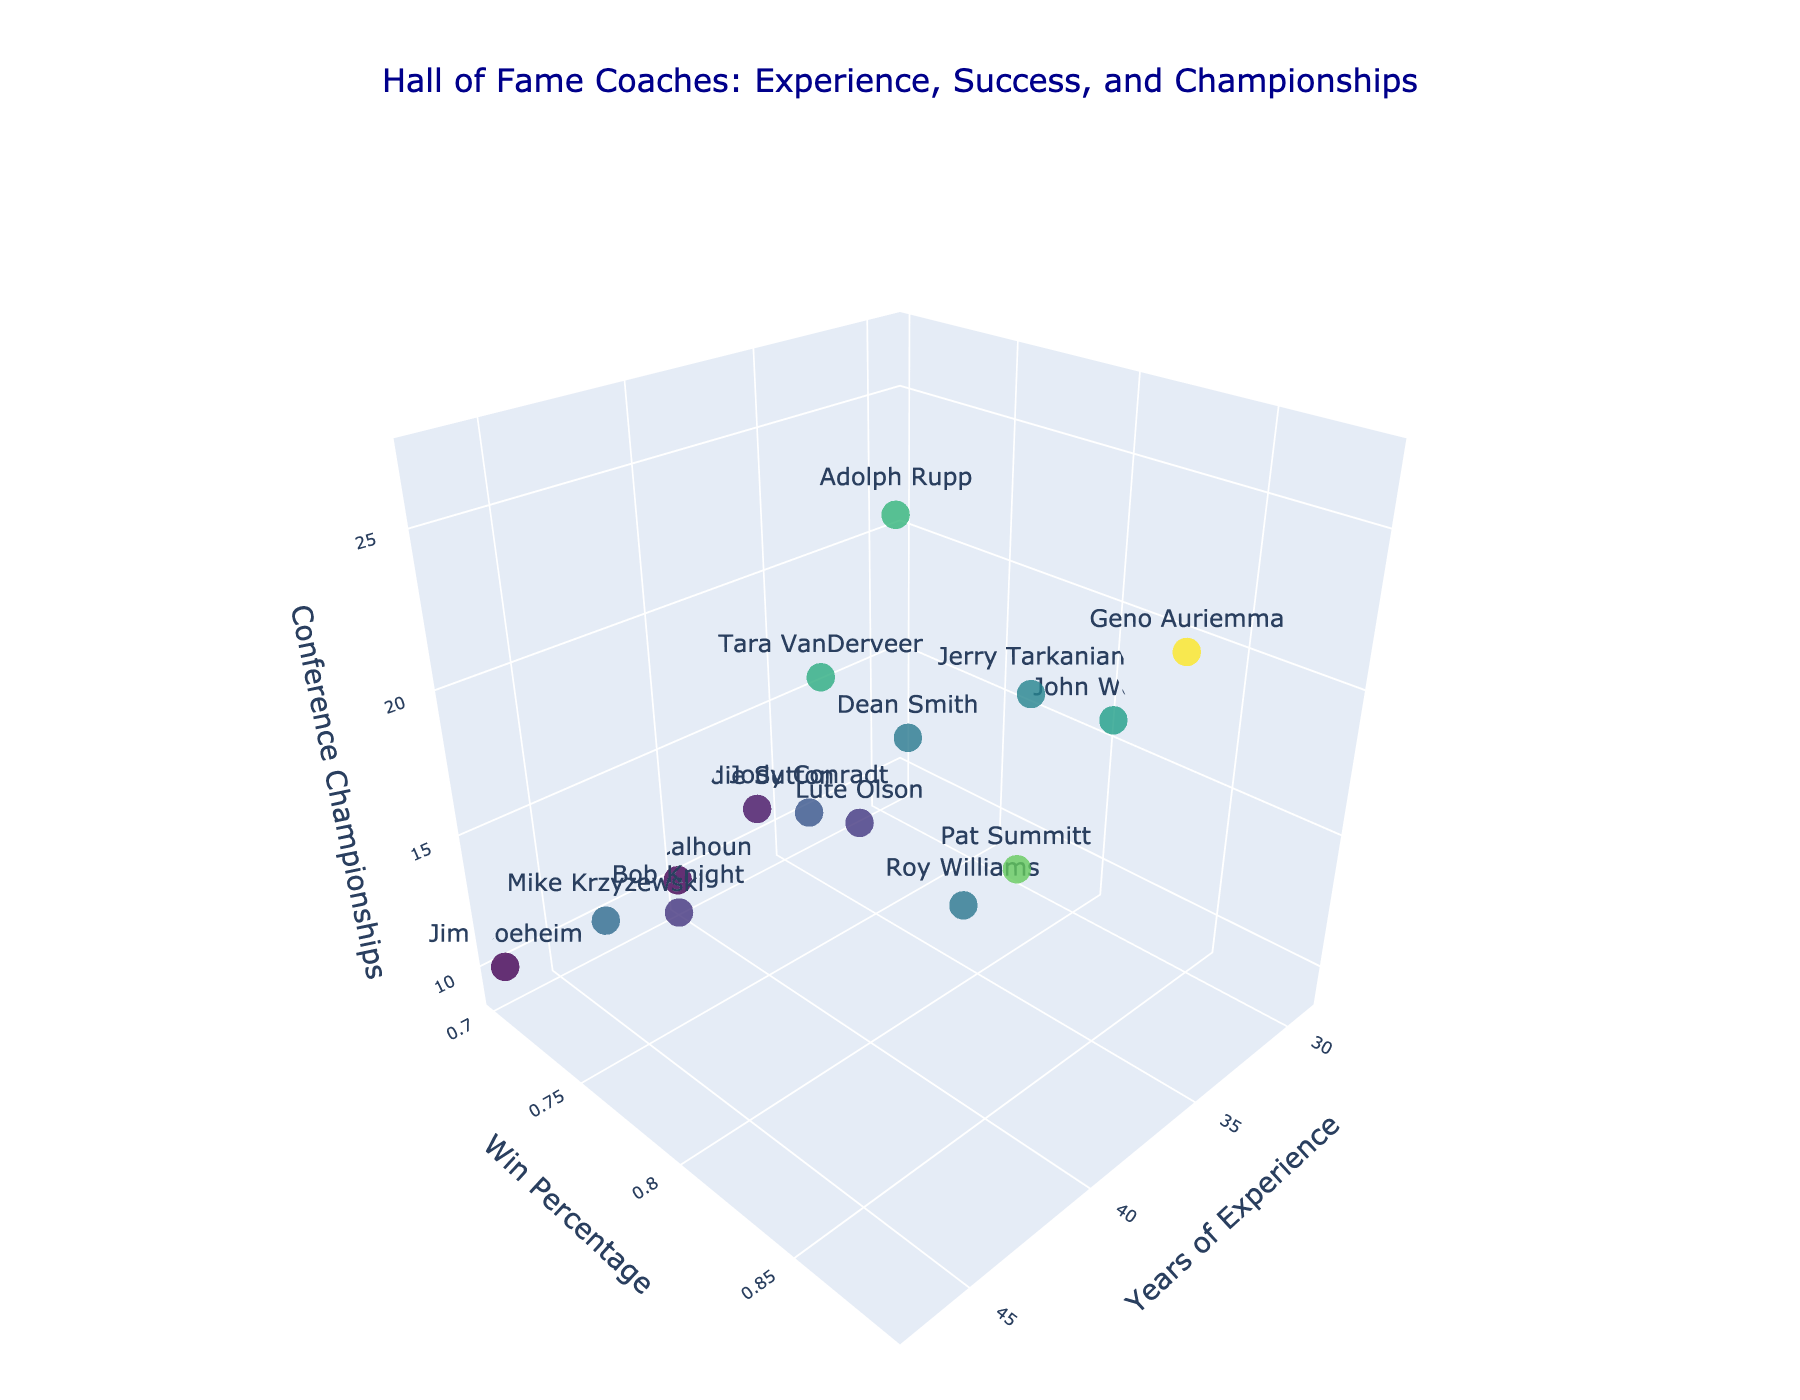What's the title of the figure? The title is located at the top of the figure. It reads "Hall of Fame Coaches: Experience, Success, and Championships".
Answer: Hall of Fame Coaches: Experience, Success, and Championships What is the color scale used for the markers in the 3D plot? The markers use a color scale to represent different values of Win Percentage. The color scale used is 'Viridis', which transitions through various shades of blue, green, and yellow.
Answer: Viridis How many coaches have more than 40 years of experience? Look at the x-axis, which represents "Years of Experience", and count the number of data points (markers) located beyond the 40-year mark. Coaches with more than 40 years of experience are Adolph Rupp, Mike Krzyzewski, Bob Knight, Jim Boeheim, and Tara VanDerveer.
Answer: 5 Which coach has the highest win percentage, and what is their win percentage? Find the coach whose marker is at the highest position on the y-axis labeled "Win Percentage". The coach with the highest win percentage is Geno Auriemma, with a win percentage of .885.
Answer: Geno Auriemma with .885 Compare John Wooden and Pat Summitt in terms of conference championships. Who has more, and how many more? Locate the markers for John Wooden and Pat Summitt. Check the z-axis values labeled "Conference Championships" for both coaches. John Wooden has 16 championships, and Pat Summitt also has 16. Both have the same number of championships.
Answer: They have the same number, 16 Who has the most conference championships overall, and how many do they have? Look for the marker that reaches the highest value on the z-axis labeled "Conference Championships". Adolph Rupp has the most with 27 championships.
Answer: Adolph Rupp with 27 Which coach has the least win percentage and what is that percentage? Find the coach whose marker is at the lowest position on the y-axis labeled "Win Percentage". The coach with the lowest win percentage is Jim Boeheim, with a win percentage of .701.
Answer: Jim Boeheim with .701 How do Dean Smith and Roy Williams compare in years of experience? Who has more, and by how many years? Locate the markers for Dean Smith and Roy Williams. Check the x-axis values labeled "Years of Experience". Dean Smith has 36 years, and Roy Williams has 33 years. Dean Smith has 3 more years of experience than Roy Williams.
Answer: Dean Smith has 3 more years What's the average win percentage of all coaches in the figure? Sum the win percentages of all coaches (0.804 + 0.776 + 0.765 + 0.822 + 0.841 + 0.885 + 0.729 + 0.701 + 0.774 + 0.815 + 0.784 + 0.701 + 0.731 + 0.710 + 0.750) and divide by the number of coaches (15). The total sum is 11.488. Average = 11.488 / 15.
Answer: 0.766 